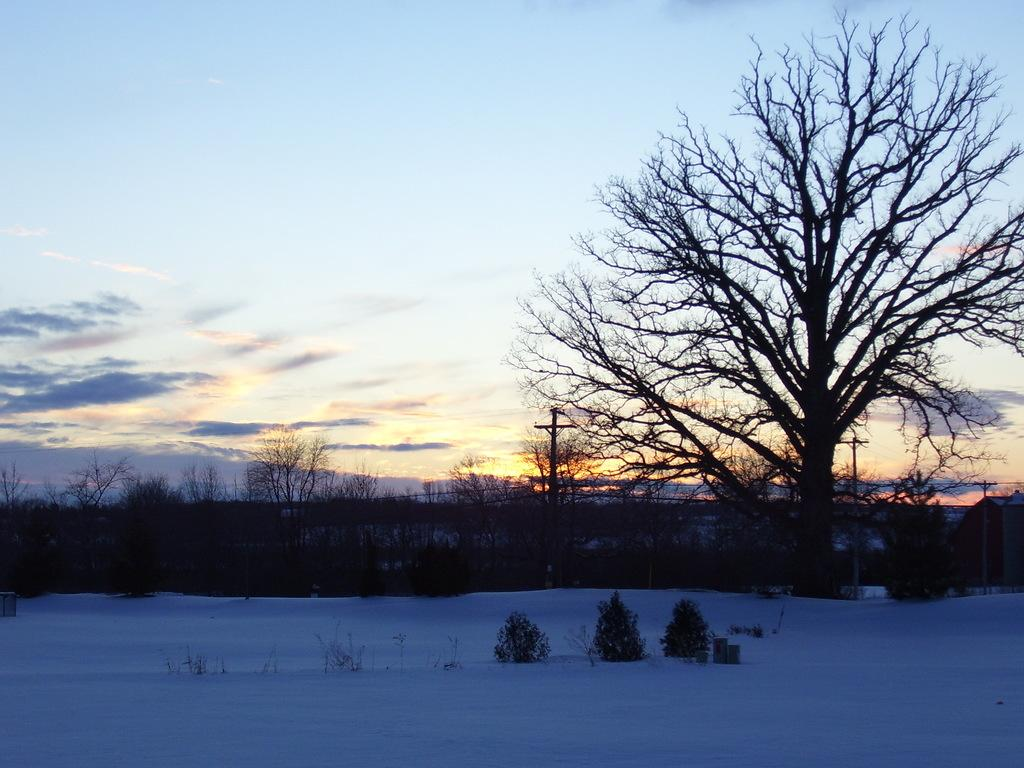What type of weather is depicted in the image? There is snow in the image, indicating a winter scene. What other elements can be seen in the image besides the snow? There are plants and trees visible in the image. What can be seen in the background of the image? The sky, the sun, and trees are visible in the background of the image. What type of account is being discussed in the image? There is no account being discussed in the image; it features a winter scene with snow, plants, trees, and a sky with the sun visible. Can you see any books or pens in the image? No, there are no books or pens present in the image. 